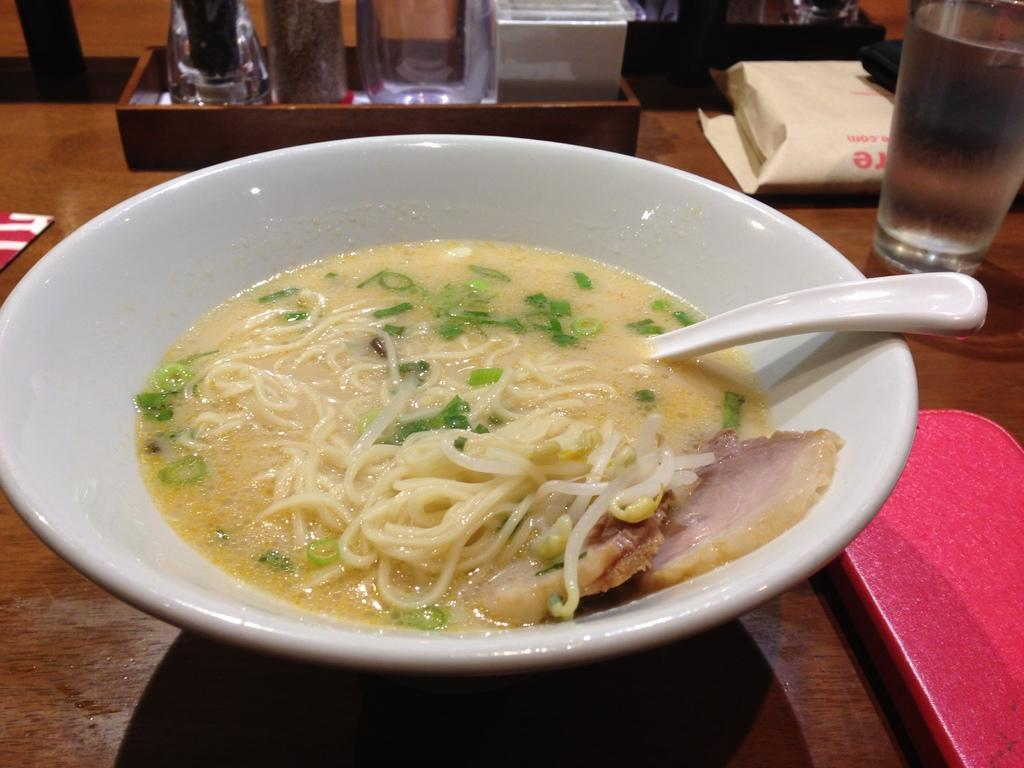What is the color of the bowl in the image? The bowl is white in color. What is inside the bowl? There is a food item in the bowl. What utensil is present in the bowl? There is a spoon in the bowl. What type of surface is beneath the bowl? The surface beneath the bowl is wooden. What other items can be seen in the image besides the bowl? There is a glass and a paper bag in the image, as well as other objects. Can you see any wings on the food item in the bowl? There are no wings visible on the food item in the bowl. Are there any icicles hanging from the glass in the image? There are no icicles present in the image. 